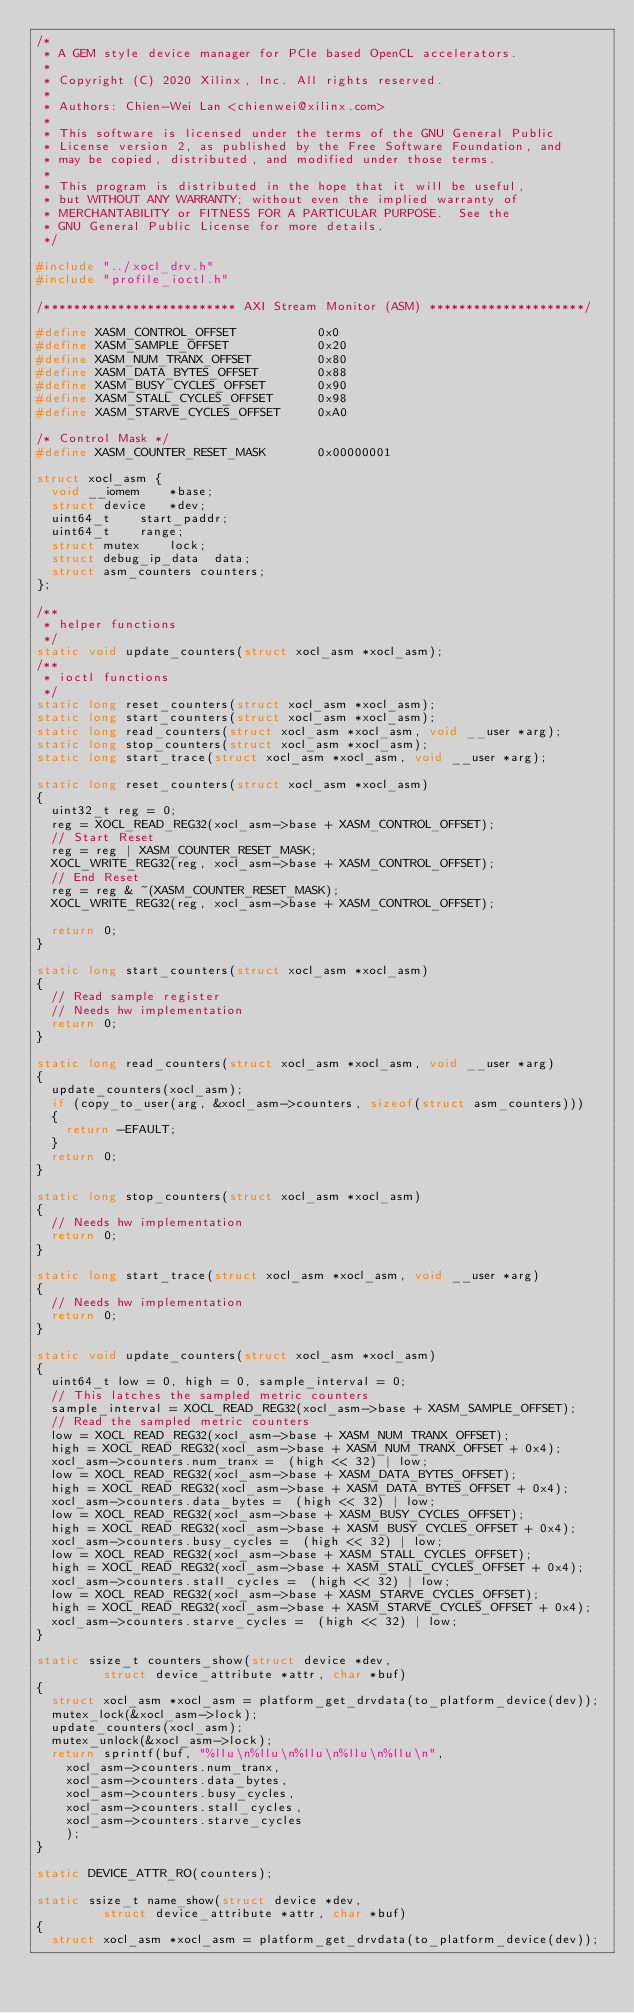Convert code to text. <code><loc_0><loc_0><loc_500><loc_500><_C_>/*
 * A GEM style device manager for PCIe based OpenCL accelerators.
 *
 * Copyright (C) 2020 Xilinx, Inc. All rights reserved.
 *
 * Authors: Chien-Wei Lan <chienwei@xilinx.com>
 *
 * This software is licensed under the terms of the GNU General Public
 * License version 2, as published by the Free Software Foundation, and
 * may be copied, distributed, and modified under those terms.
 *
 * This program is distributed in the hope that it will be useful,
 * but WITHOUT ANY WARRANTY; without even the implied warranty of
 * MERCHANTABILITY or FITNESS FOR A PARTICULAR PURPOSE.  See the
 * GNU General Public License for more details.
 */

#include "../xocl_drv.h"
#include "profile_ioctl.h"

/************************** AXI Stream Monitor (ASM) *********************/

#define XASM_CONTROL_OFFSET           0x0
#define XASM_SAMPLE_OFFSET            0x20
#define XASM_NUM_TRANX_OFFSET         0x80
#define XASM_DATA_BYTES_OFFSET        0x88
#define XASM_BUSY_CYCLES_OFFSET       0x90
#define XASM_STALL_CYCLES_OFFSET      0x98
#define XASM_STARVE_CYCLES_OFFSET     0xA0

/* Control Mask */
#define XASM_COUNTER_RESET_MASK       0x00000001

struct xocl_asm {
	void __iomem		*base;
	struct device		*dev;
	uint64_t		start_paddr;
	uint64_t		range;
	struct mutex 		lock;
	struct debug_ip_data	data;
	struct asm_counters	counters;
};

/**
 * helper functions
 */
static void update_counters(struct xocl_asm *xocl_asm);
/**
 * ioctl functions
 */
static long reset_counters(struct xocl_asm *xocl_asm);
static long start_counters(struct xocl_asm *xocl_asm);
static long read_counters(struct xocl_asm *xocl_asm, void __user *arg);
static long stop_counters(struct xocl_asm *xocl_asm);
static long start_trace(struct xocl_asm *xocl_asm, void __user *arg);

static long reset_counters(struct xocl_asm *xocl_asm)
{
	uint32_t reg = 0;
	reg = XOCL_READ_REG32(xocl_asm->base + XASM_CONTROL_OFFSET);
	// Start Reset
	reg = reg | XASM_COUNTER_RESET_MASK;
	XOCL_WRITE_REG32(reg, xocl_asm->base + XASM_CONTROL_OFFSET);
	// End Reset
	reg = reg & ~(XASM_COUNTER_RESET_MASK);
	XOCL_WRITE_REG32(reg, xocl_asm->base + XASM_CONTROL_OFFSET);

	return 0;
}

static long start_counters(struct xocl_asm *xocl_asm)
{
	// Read sample register
	// Needs hw implementation
	return 0;
}

static long read_counters(struct xocl_asm *xocl_asm, void __user *arg)
{
	update_counters(xocl_asm);
	if (copy_to_user(arg, &xocl_asm->counters, sizeof(struct asm_counters)))
	{
		return -EFAULT;
	}
	return 0;
}

static long stop_counters(struct xocl_asm *xocl_asm)
{
	// Needs hw implementation
	return 0;
}

static long start_trace(struct xocl_asm *xocl_asm, void __user *arg)
{
	// Needs hw implementation
	return 0;
}

static void update_counters(struct xocl_asm *xocl_asm)
{
	uint64_t low = 0, high = 0, sample_interval = 0;
	// This latches the sampled metric counters
	sample_interval = XOCL_READ_REG32(xocl_asm->base + XASM_SAMPLE_OFFSET);
	// Read the sampled metric counters
	low = XOCL_READ_REG32(xocl_asm->base + XASM_NUM_TRANX_OFFSET);
	high = XOCL_READ_REG32(xocl_asm->base + XASM_NUM_TRANX_OFFSET + 0x4);
	xocl_asm->counters.num_tranx =  (high << 32) | low;
	low = XOCL_READ_REG32(xocl_asm->base + XASM_DATA_BYTES_OFFSET);
	high = XOCL_READ_REG32(xocl_asm->base + XASM_DATA_BYTES_OFFSET + 0x4);
	xocl_asm->counters.data_bytes =  (high << 32) | low;
	low = XOCL_READ_REG32(xocl_asm->base + XASM_BUSY_CYCLES_OFFSET);
	high = XOCL_READ_REG32(xocl_asm->base + XASM_BUSY_CYCLES_OFFSET + 0x4);
	xocl_asm->counters.busy_cycles =  (high << 32) | low;
	low = XOCL_READ_REG32(xocl_asm->base + XASM_STALL_CYCLES_OFFSET);
	high = XOCL_READ_REG32(xocl_asm->base + XASM_STALL_CYCLES_OFFSET + 0x4);
	xocl_asm->counters.stall_cycles =  (high << 32) | low;
	low = XOCL_READ_REG32(xocl_asm->base + XASM_STARVE_CYCLES_OFFSET);
	high = XOCL_READ_REG32(xocl_asm->base + XASM_STARVE_CYCLES_OFFSET + 0x4);
	xocl_asm->counters.starve_cycles =  (high << 32) | low;
}

static ssize_t counters_show(struct device *dev,
			   struct device_attribute *attr, char *buf)
{
	struct xocl_asm *xocl_asm = platform_get_drvdata(to_platform_device(dev));
	mutex_lock(&xocl_asm->lock);
	update_counters(xocl_asm);
	mutex_unlock(&xocl_asm->lock);
	return sprintf(buf, "%llu\n%llu\n%llu\n%llu\n%llu\n",
		xocl_asm->counters.num_tranx,
		xocl_asm->counters.data_bytes,
		xocl_asm->counters.busy_cycles,
		xocl_asm->counters.stall_cycles,
		xocl_asm->counters.starve_cycles
		);
}

static DEVICE_ATTR_RO(counters);

static ssize_t name_show(struct device *dev,
			   struct device_attribute *attr, char *buf)
{
	struct xocl_asm *xocl_asm = platform_get_drvdata(to_platform_device(dev));</code> 